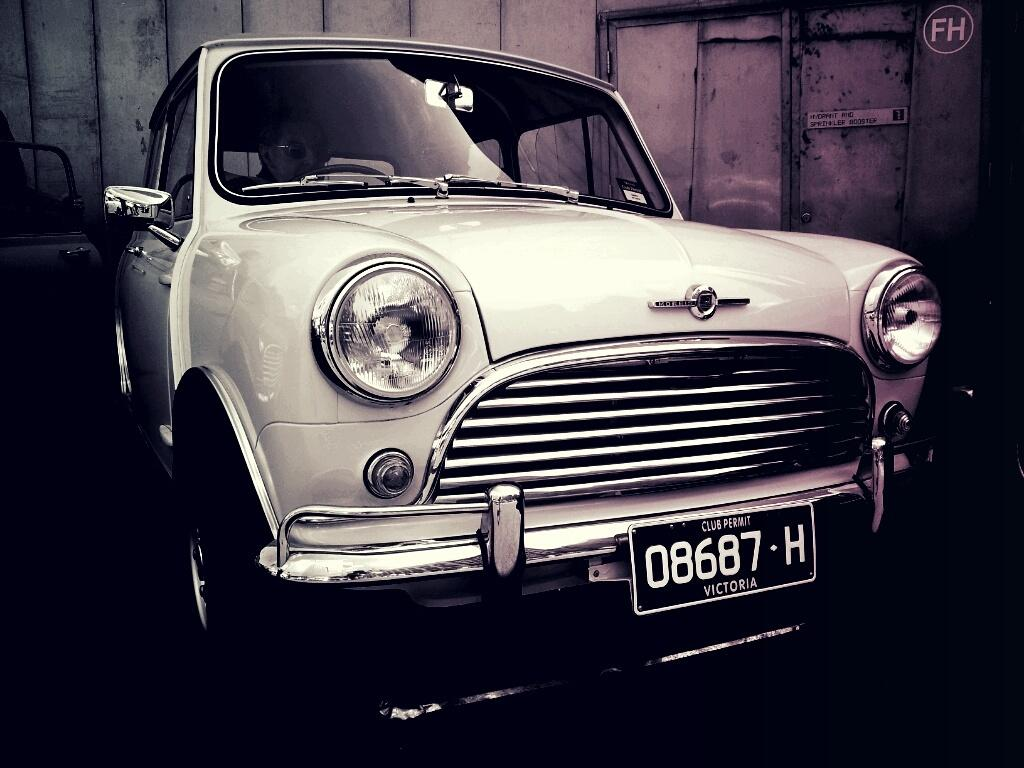Provide a one-sentence caption for the provided image. A classic automobile with the license tag 08687-H. 